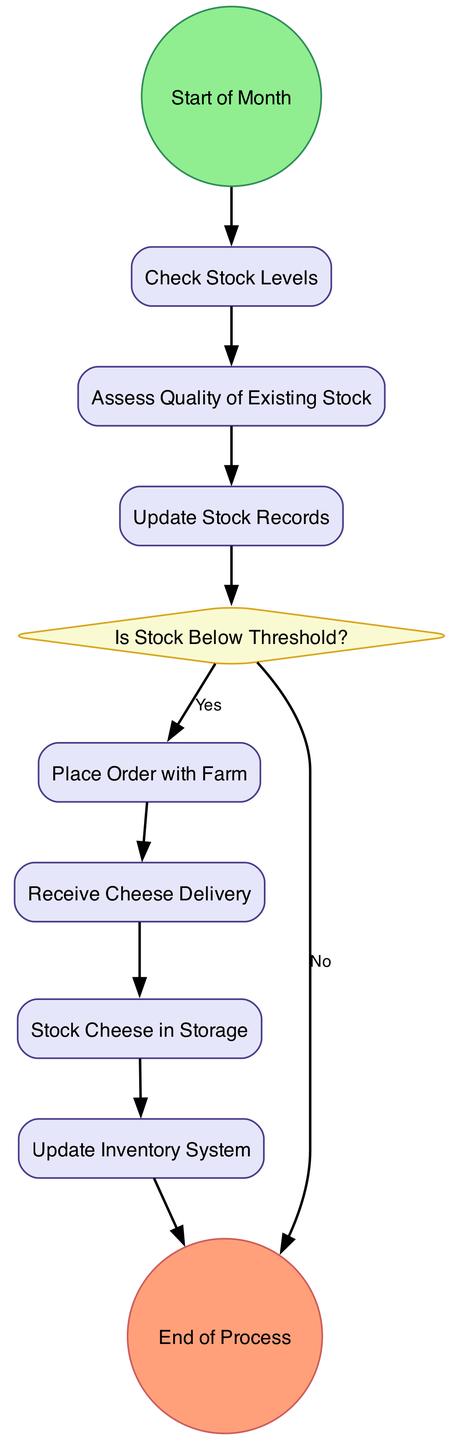What is the first activity that occurs at the start of the month? The diagram indicates that the first activity that occurs at the start of the month is "Check Stock Levels." This is the first node following the "Start" event.
Answer: Check Stock Levels How many decision points are present in the diagram? There is one decision point in the diagram, identified as "Is Stock Below Threshold?" This is the only diamond-shaped node, indicating a decision.
Answer: 1 What are the last two activities before reaching the end of the process? The last two activities before reaching the end of the process are "Update Inventory System" and "Stock Cheese in Storage." These activities lead directly to the "End" event node.
Answer: Update Inventory System, Stock Cheese in Storage What action is taken when the stock is below the threshold? When the stock is below the threshold, the action taken is to "Place Order with Farm." This follows the decision point when the answer is "Yes."
Answer: Place Order with Farm What happens after the "Assess Quality of Existing Stock" activity? After the "Assess Quality of Existing Stock" activity, the next activity is "Update Stock Records." This step documents the results from assessing the quality before any decisions are made regarding stock levels.
Answer: Update Stock Records Which activity involves verifying the quality and quantity of cheese? The activity that involves verifying the quality and quantity of cheese is "Receive Cheese Delivery." This occurs after placing an order with the farm, ensuring that the received stock meets standards.
Answer: Receive Cheese Delivery 